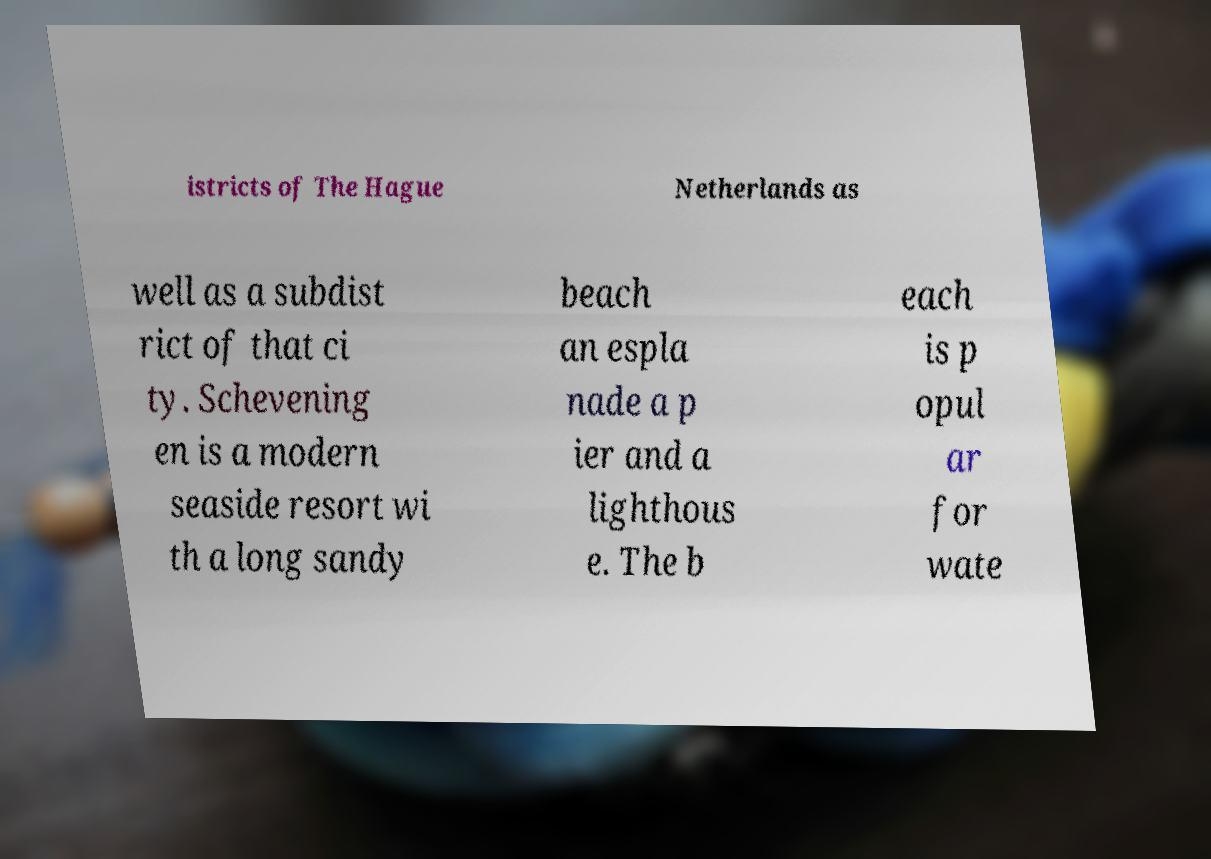For documentation purposes, I need the text within this image transcribed. Could you provide that? istricts of The Hague Netherlands as well as a subdist rict of that ci ty. Schevening en is a modern seaside resort wi th a long sandy beach an espla nade a p ier and a lighthous e. The b each is p opul ar for wate 